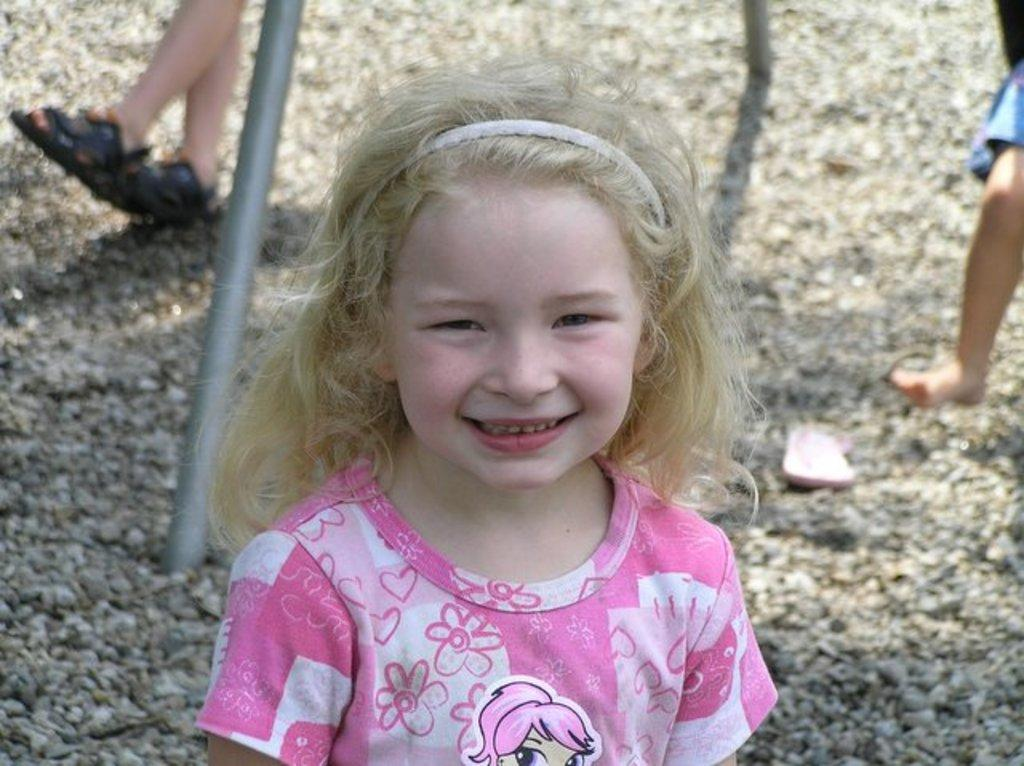Who is present in the image? There is a girl in the image. What is the girl doing in the image? The girl is smiling in the image. What can be seen in the background of the image? There are stones, two persons, an iron rod, and a slipper in the background of the image. What type of chalk is the girl using to draw on the stones in the image? There is no chalk present in the image, and the girl is not drawing on the stones. 